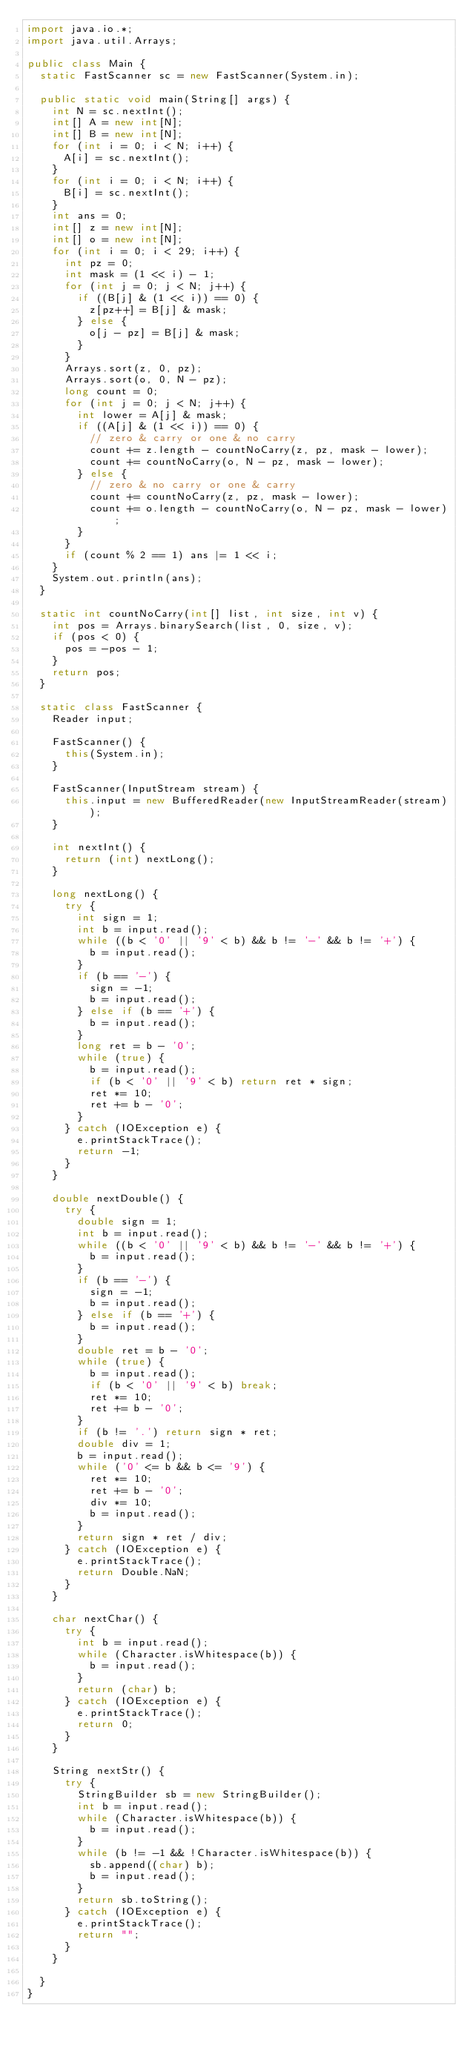<code> <loc_0><loc_0><loc_500><loc_500><_Java_>import java.io.*;
import java.util.Arrays;

public class Main {
  static FastScanner sc = new FastScanner(System.in);

  public static void main(String[] args) {
    int N = sc.nextInt();
    int[] A = new int[N];
    int[] B = new int[N];
    for (int i = 0; i < N; i++) {
      A[i] = sc.nextInt();
    }
    for (int i = 0; i < N; i++) {
      B[i] = sc.nextInt();
    }
    int ans = 0;
    int[] z = new int[N];
    int[] o = new int[N];
    for (int i = 0; i < 29; i++) {
      int pz = 0;
      int mask = (1 << i) - 1;
      for (int j = 0; j < N; j++) {
        if ((B[j] & (1 << i)) == 0) {
          z[pz++] = B[j] & mask;
        } else {
          o[j - pz] = B[j] & mask;
        }
      }
      Arrays.sort(z, 0, pz);
      Arrays.sort(o, 0, N - pz);
      long count = 0;
      for (int j = 0; j < N; j++) {
        int lower = A[j] & mask;
        if ((A[j] & (1 << i)) == 0) {
          // zero & carry or one & no carry
          count += z.length - countNoCarry(z, pz, mask - lower);
          count += countNoCarry(o, N - pz, mask - lower);
        } else {
          // zero & no carry or one & carry
          count += countNoCarry(z, pz, mask - lower);
          count += o.length - countNoCarry(o, N - pz, mask - lower);
        }
      }
      if (count % 2 == 1) ans |= 1 << i;
    }
    System.out.println(ans);
  }

  static int countNoCarry(int[] list, int size, int v) {
    int pos = Arrays.binarySearch(list, 0, size, v);
    if (pos < 0) {
      pos = -pos - 1;
    }
    return pos;
  }

  static class FastScanner {
    Reader input;

    FastScanner() {
      this(System.in);
    }

    FastScanner(InputStream stream) {
      this.input = new BufferedReader(new InputStreamReader(stream));
    }

    int nextInt() {
      return (int) nextLong();
    }

    long nextLong() {
      try {
        int sign = 1;
        int b = input.read();
        while ((b < '0' || '9' < b) && b != '-' && b != '+') {
          b = input.read();
        }
        if (b == '-') {
          sign = -1;
          b = input.read();
        } else if (b == '+') {
          b = input.read();
        }
        long ret = b - '0';
        while (true) {
          b = input.read();
          if (b < '0' || '9' < b) return ret * sign;
          ret *= 10;
          ret += b - '0';
        }
      } catch (IOException e) {
        e.printStackTrace();
        return -1;
      }
    }

    double nextDouble() {
      try {
        double sign = 1;
        int b = input.read();
        while ((b < '0' || '9' < b) && b != '-' && b != '+') {
          b = input.read();
        }
        if (b == '-') {
          sign = -1;
          b = input.read();
        } else if (b == '+') {
          b = input.read();
        }
        double ret = b - '0';
        while (true) {
          b = input.read();
          if (b < '0' || '9' < b) break;
          ret *= 10;
          ret += b - '0';
        }
        if (b != '.') return sign * ret;
        double div = 1;
        b = input.read();
        while ('0' <= b && b <= '9') {
          ret *= 10;
          ret += b - '0';
          div *= 10;
          b = input.read();
        }
        return sign * ret / div;
      } catch (IOException e) {
        e.printStackTrace();
        return Double.NaN;
      }
    }

    char nextChar() {
      try {
        int b = input.read();
        while (Character.isWhitespace(b)) {
          b = input.read();
        }
        return (char) b;
      } catch (IOException e) {
        e.printStackTrace();
        return 0;
      }
    }

    String nextStr() {
      try {
        StringBuilder sb = new StringBuilder();
        int b = input.read();
        while (Character.isWhitespace(b)) {
          b = input.read();
        }
        while (b != -1 && !Character.isWhitespace(b)) {
          sb.append((char) b);
          b = input.read();
        }
        return sb.toString();
      } catch (IOException e) {
        e.printStackTrace();
        return "";
      }
    }

  }
}
</code> 